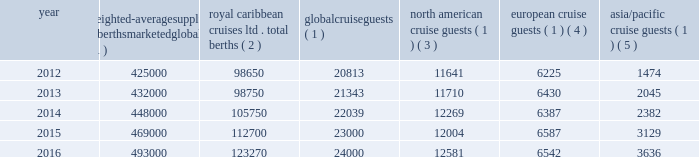The table details the growth in global weighted average berths and the global , north american , european and asia/pacific cruise guests over the past five years ( in thousands , except berth data ) : weighted- average supply of berths marketed globally ( 1 ) caribbean cruises ltd .
Total berths ( 2 ) global cruise guests ( 1 ) american cruise guests ( 1 ) ( 3 ) european cruise guests ( 1 ) ( 4 ) asia/pacific cruise guests ( 1 ) ( 5 ) .
_______________________________________________________________________________ ( 1 ) source : our estimates of the number of global cruise guests and the weighted-average supply of berths marketed globally are based on a combination of data that we obtain from various publicly available cruise industry trade information sources .
We use data obtained from seatrade insider , cruise industry news and company press releases to estimate weighted-average supply of berths and clia and g.p .
Wild to estimate cruise guest information .
In addition , our estimates incorporate our own statistical analysis utilizing the same publicly available cruise industry data as a base .
( 2 ) total berths include our berths related to our global brands and partner brands .
( 3 ) our estimates include the united states and canada .
( 4 ) our estimates include european countries relevant to the industry ( e.g. , nordics , germany , france , italy , spain and the united kingdom ) .
( 5 ) our estimates include the southeast asia ( e.g. , singapore , thailand and the philippines ) , east asia ( e.g. , china and japan ) , south asia ( e.g. , india and pakistan ) and oceanian ( e.g. , australia and fiji islands ) regions .
North america the majority of industry cruise guests are sourced from north america , which represented approximately 52% ( 52 % ) of global cruise guests in 2016 .
The compound annual growth rate in cruise guests sourced from this market was approximately 2% ( 2 % ) from 2012 to 2016 .
Europe industry cruise guests sourced from europe represented approximately 27% ( 27 % ) of global cruise guests in 2016 .
The compound annual growth rate in cruise guests sourced from this market was approximately 1% ( 1 % ) from 2012 to 2016 .
Asia/pacific industry cruise guests sourced from the asia/pacific region represented approximately 15% ( 15 % ) of global cruise guests in 2016 .
The compound annual growth rate in cruise guests sourced from this market was approximately 25% ( 25 % ) from 2012 to 2016 .
The asia/pacific region is experiencing the highest growth rate of the major regions , although it will continue to represent a relatively small sector compared to north america .
Competition we compete with a number of cruise lines .
Our principal competitors are carnival corporation & plc , which owns , among others , aida cruises , carnival cruise line , costa cruises , cunard line , holland america line , p&o cruises , princess cruises and seabourn ; disney cruise line ; msc cruises ; and norwegian cruise line holdings ltd , which owns norwegian cruise line , oceania cruises and regent seven seas cruises .
Cruise lines compete with .
What percentage increase in asian cruise guests occurred between 2012 and 2016? 
Computations: (((3636 - 1474) / 1474) * 100)
Answer: 146.67571. 